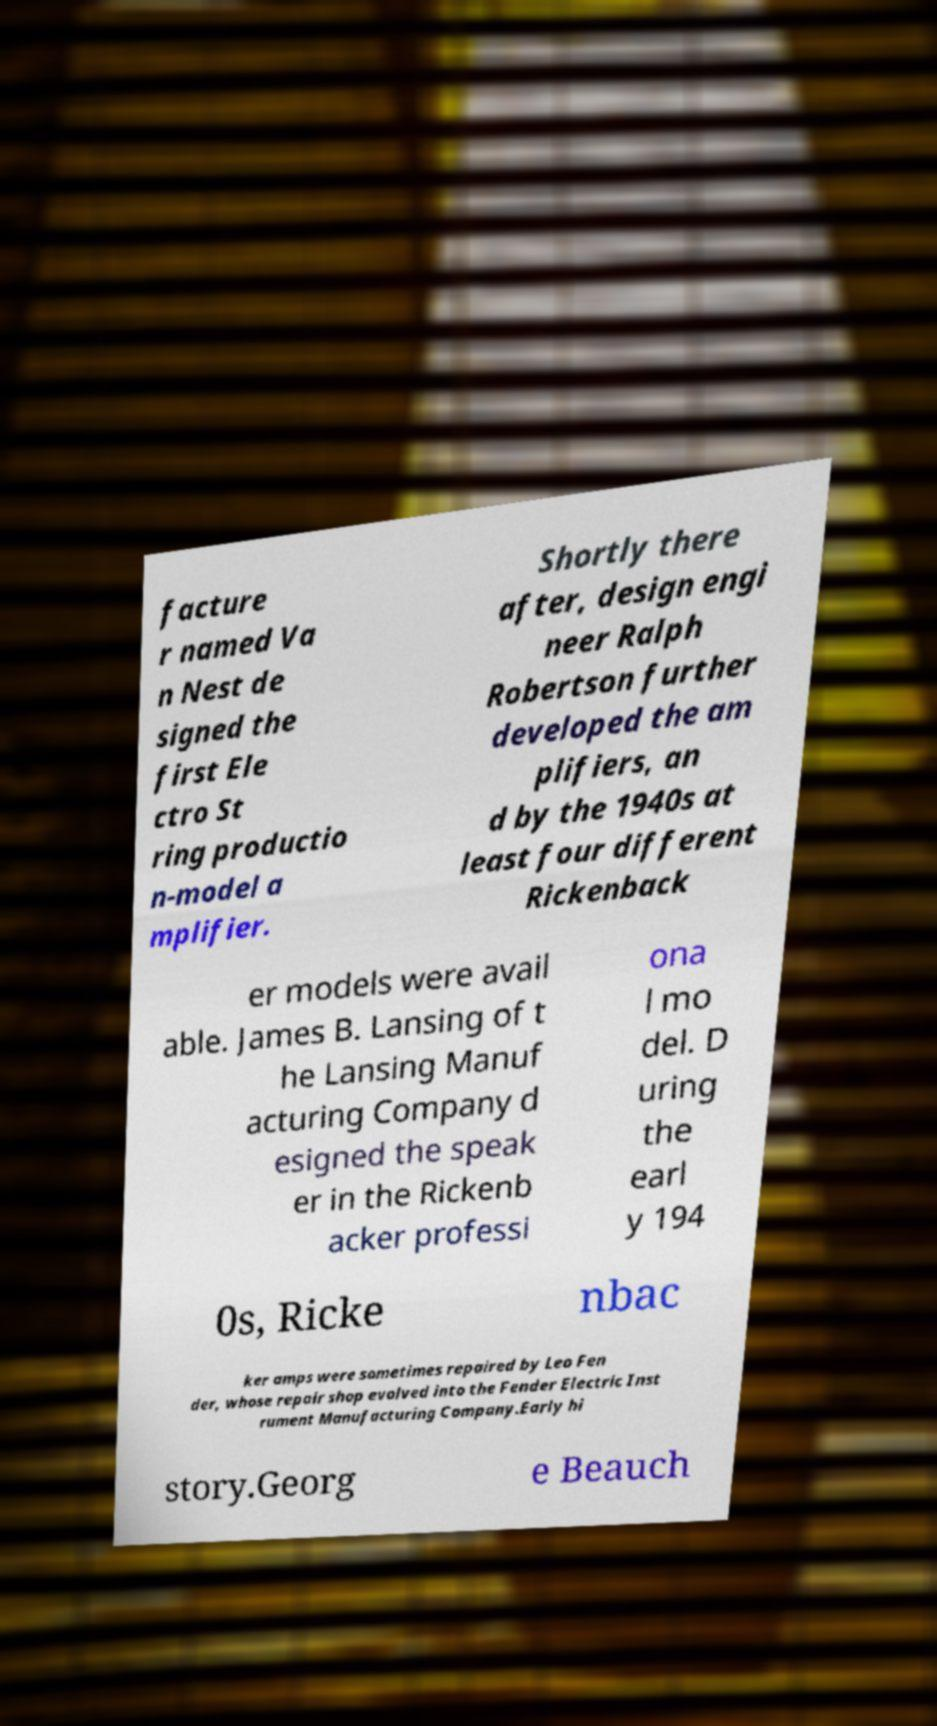Can you read and provide the text displayed in the image?This photo seems to have some interesting text. Can you extract and type it out for me? facture r named Va n Nest de signed the first Ele ctro St ring productio n-model a mplifier. Shortly there after, design engi neer Ralph Robertson further developed the am plifiers, an d by the 1940s at least four different Rickenback er models were avail able. James B. Lansing of t he Lansing Manuf acturing Company d esigned the speak er in the Rickenb acker professi ona l mo del. D uring the earl y 194 0s, Ricke nbac ker amps were sometimes repaired by Leo Fen der, whose repair shop evolved into the Fender Electric Inst rument Manufacturing Company.Early hi story.Georg e Beauch 